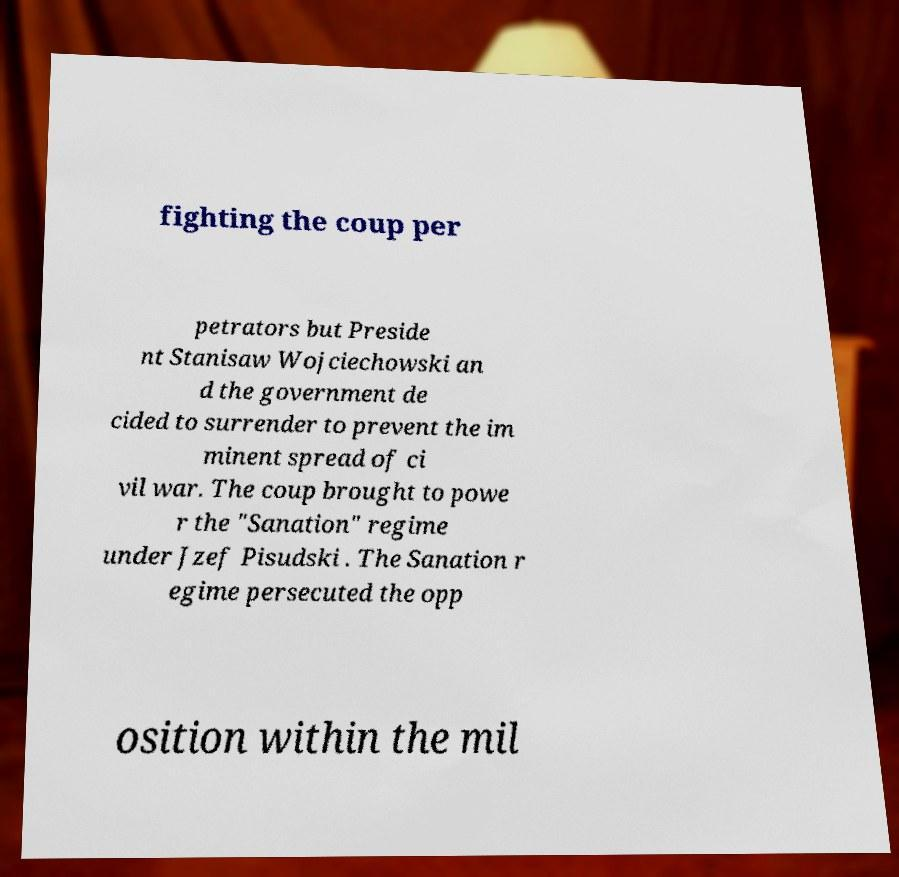Could you assist in decoding the text presented in this image and type it out clearly? fighting the coup per petrators but Preside nt Stanisaw Wojciechowski an d the government de cided to surrender to prevent the im minent spread of ci vil war. The coup brought to powe r the "Sanation" regime under Jzef Pisudski . The Sanation r egime persecuted the opp osition within the mil 